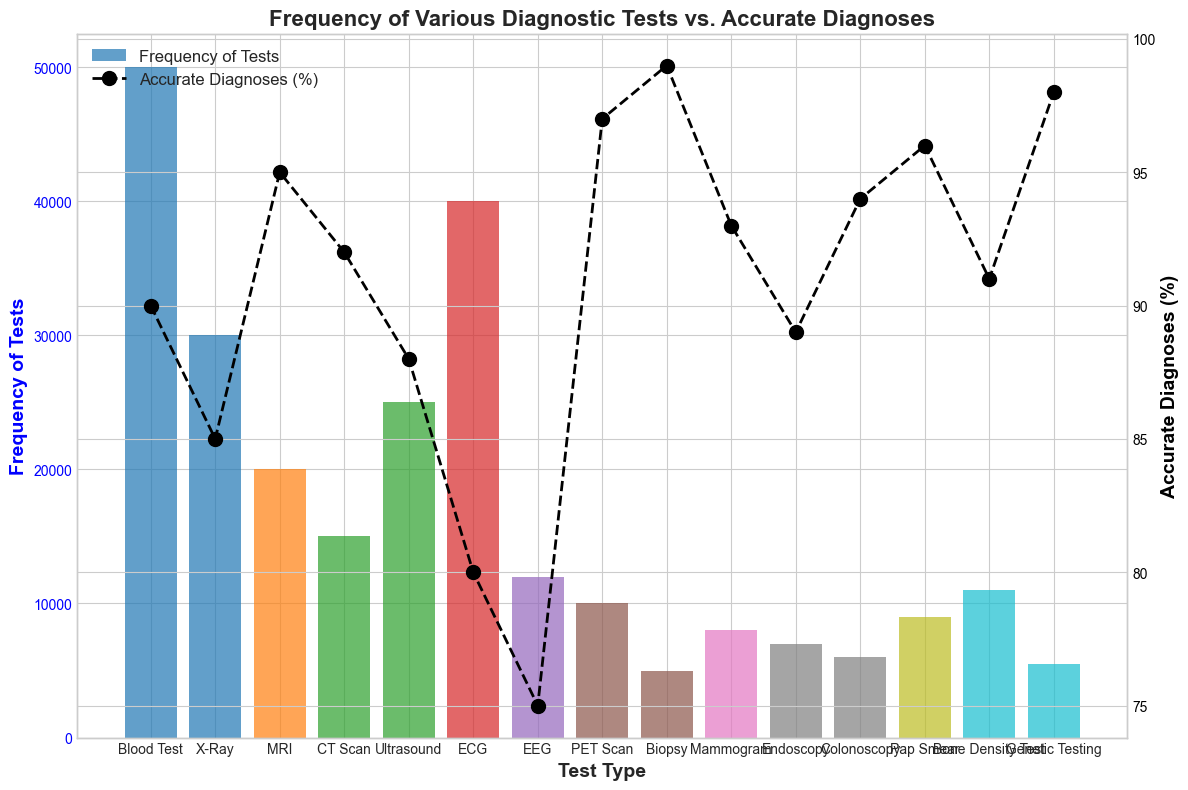How many more Blood Tests are performed compared to MRIs? First, identify the bar height for Blood Tests (50000) and for MRIs (20000). Then, subtract the number of MRIs from the number of Blood Tests: 50000 - 20000 = 30000.
Answer: 30000 Which diagnostic test has the highest rate of accurate diagnoses? Look at the line plot and identify the highest point, which corresponds to PET Scan with an accurate diagnosis rate of 97%.
Answer: PET Scan What is the average frequency of PET Scan and Biopsy tests combined? Locate the bars for PET Scan (10000) and Biopsy (5000), add these values together and divide by 2: (10000 + 5000) / 2 = 7500.
Answer: 7500 Is the frequency of Endoscopy tests higher or lower than Mammogram tests? Compare the bar heights for Endoscopy (7000) and Mammogram (8000). Endoscopy's bar is shorter.
Answer: Lower Which test type has the most balanced combination of high frequency and high accurate diagnoses? Blood Tests have a high frequency of 50000 and an accurate diagnosis rate of 90%. Other tests may have a higher percentage but much lower frequency.
Answer: Blood Test How many fewer accurate diagnoses Percentage does an X-Ray have compared to an Ultrasound? X-Ray has 85% accurate diagnoses and Ultrasound has 88%. Subtract the two percentages: 88% - 85% = 3%.
Answer: 3% Identify the test with the lowest frequency. Look for the shortest bar in the plot, which corresponds to Biopsy with 5000 tests performed.
Answer: Biopsy Are there more tests performed using ECG or Ultrasound? Compare the bar heights for ECG (40000) and Ultrasound (25000). ECG's bar is taller.
Answer: ECG What is the overall trend in accurate diagnosis rates as test frequency decreases? There is no consistent trend as some tests with lower frequency like PET Scan and Biopsy have very high accurate diagnosis rates, while others like EEG with lower frequency have lower accurate diagnosis rates.
Answer: Inconsistent trend Which diagnostic test has nearly the same frequency as its accurate diagnosis rate? Blood Test has a frequency of 50000 and an accurate diagnosis rate of 90%, which is conceptually much larger, but no tests have similar frequency and percentage.
Answer: None 